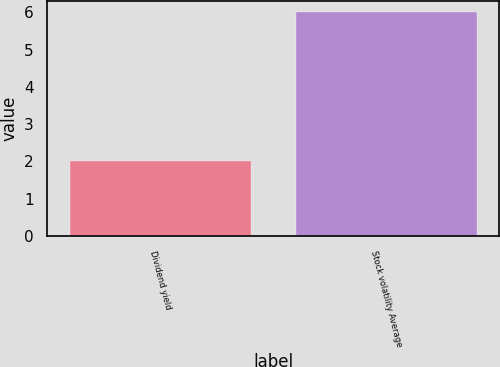Convert chart to OTSL. <chart><loc_0><loc_0><loc_500><loc_500><bar_chart><fcel>Dividend yield<fcel>Stock volatility Average<nl><fcel>2<fcel>6<nl></chart> 